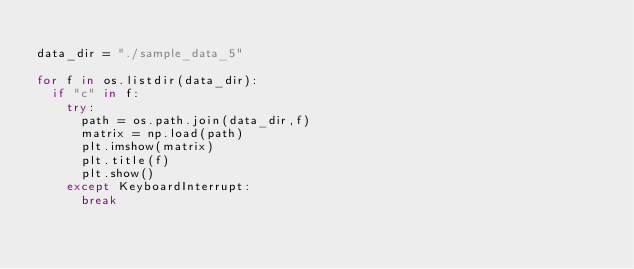Convert code to text. <code><loc_0><loc_0><loc_500><loc_500><_Python_>
data_dir = "./sample_data_5"

for f in os.listdir(data_dir):
	if "c" in f:
		try:
			path = os.path.join(data_dir,f)
			matrix = np.load(path)
			plt.imshow(matrix)
			plt.title(f)
			plt.show()
		except KeyboardInterrupt:
			break</code> 